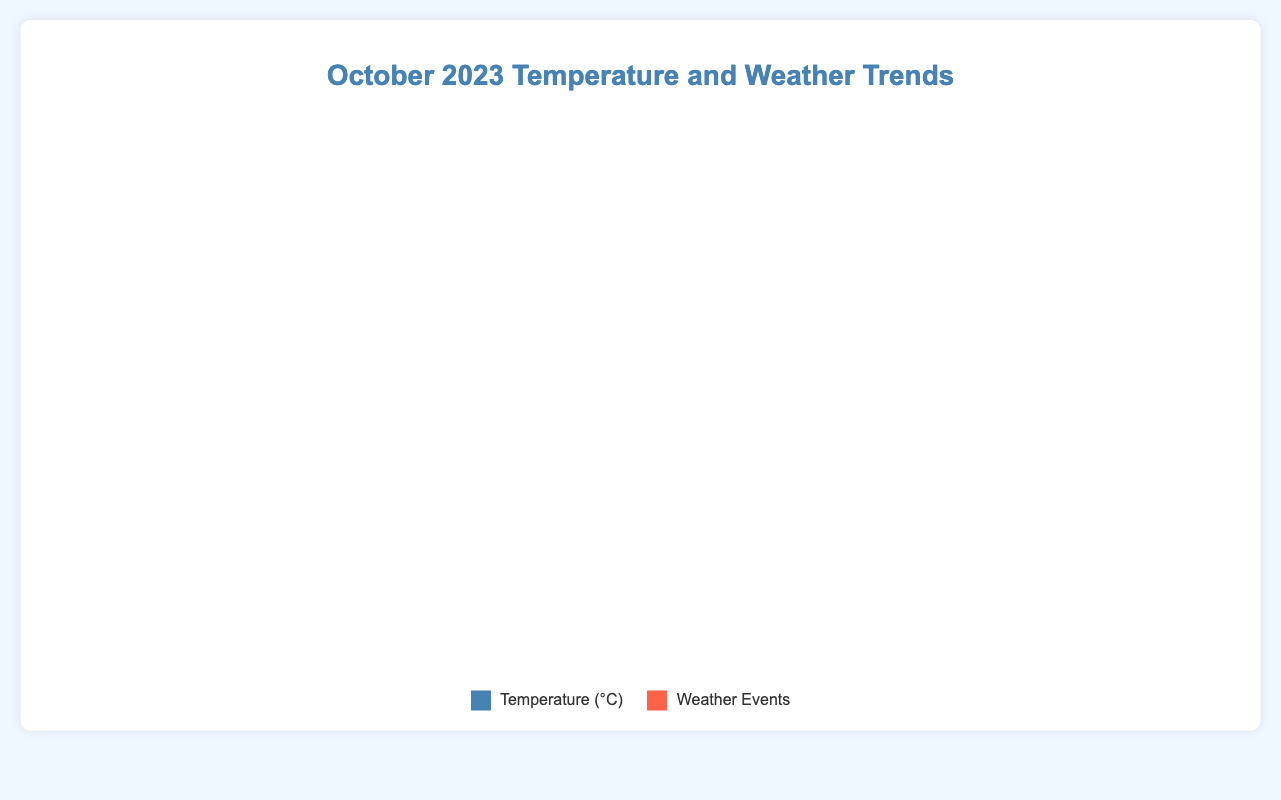Which date has the highest temperature in October 2023? To find the highest temperature, look at the y-axis value that is the tallest. The date corresponding to this highest point on the x-axis is the one you need.
Answer: October 6 On which dates did the temperature fall below 17 degrees Celsius? Identify the points on the line which are below the 17-degree mark and note their corresponding dates on the x-axis.
Answer: October 13, October 14, October 21, October 22, October 27 When was the first light rain recorded, and what was the temperature on that day? Look for the weather event annotations and find the first one marked as "Light rain". Check the temperature on that specific date.
Answer: October 3, 17.2°C What is the average temperature for the dates with heavy rain? Calculate the temperatures for dates labeled "Heavy rain" (October 7 and October 29). Then, sum those temperatures and divide by the number of these instances.  [(18.5 + 18.0) / 2]
Answer: 18.25°C How does the temperature on October 12 during the thunderstorm compare to the temperature on October 14 when it was sunny? Check the temperature values on both dates indicated by weather events and compare. The temperature on October 12 is 18.3°C, and on October 14, it is 16.8°C.
Answer: Higher on October 12 What is the overall temperature trend during the month of October 2023? Analyze the line chart's overall direction from the start to the end of the month. The line rises and falls but generally remains within a narrow range with slight fluctuations.
Answer: Slightly fluctuating On which date did the temperature peak, and what weather event happened closest to that date? Find the date with the highest temperature and check nearby dates if a weather event is mentioned. The peak temperature occurred on October 6. The closest weather event is the Thunderstorm on October 12.
Answer: October 6, Thunderstorm on October 12 How many days after the October 12 thunderstorm did the next weather event occur? Identify the date of the next weather event after October 12 by checking the next weather event annotation. The next event is Sunny on October 14. Calculate the difference in days (14 - 12).
Answer: 2 days What was the temperature trend from October 15 to October 17? Check the dates on the x-axis from October 15 to October 17 and observe the temperature values. The temperatures are 17.4°C, 18.2°C, and 19.0°C respectively.
Answer: Increasing 